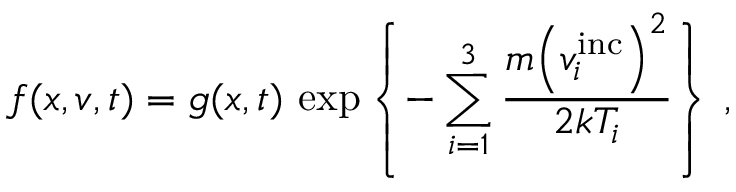Convert formula to latex. <formula><loc_0><loc_0><loc_500><loc_500>f ( x , v , t ) = g ( x , t ) \, \exp \left \{ - \sum _ { i = 1 } ^ { 3 } \frac { m { \left ( v _ { i } ^ { i n c } \right ) } ^ { 2 } } { 2 k T _ { i } } \right \} \, ,</formula> 